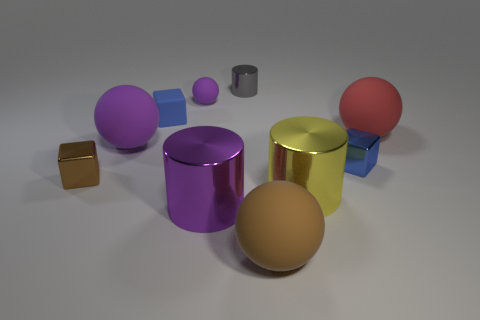The cylinder that is the same color as the tiny rubber ball is what size?
Make the answer very short. Large. What shape is the big rubber thing that is the same color as the tiny rubber ball?
Provide a succinct answer. Sphere. What number of brown things are to the left of the tiny purple ball and to the right of the small gray thing?
Your answer should be compact. 0. Are there more tiny brown cubes than large matte balls?
Provide a short and direct response. No. How many other objects are there of the same shape as the small brown shiny thing?
Your answer should be very brief. 2. Do the rubber block and the small shiny cylinder have the same color?
Offer a very short reply. No. What is the thing that is both behind the blue metallic block and to the right of the yellow shiny cylinder made of?
Your response must be concise. Rubber. What size is the brown ball?
Your answer should be very brief. Large. There is a purple sphere that is in front of the purple sphere on the right side of the blue matte block; how many purple shiny cylinders are to the left of it?
Offer a terse response. 0. There is a matte object in front of the small block on the right side of the tiny gray object; what is its shape?
Make the answer very short. Sphere. 